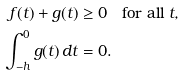Convert formula to latex. <formula><loc_0><loc_0><loc_500><loc_500>f ( t ) + g ( t ) & \geq 0 \quad \text {for all } t , \\ \int _ { - h } ^ { 0 } g ( t ) \, d t & = 0 .</formula> 